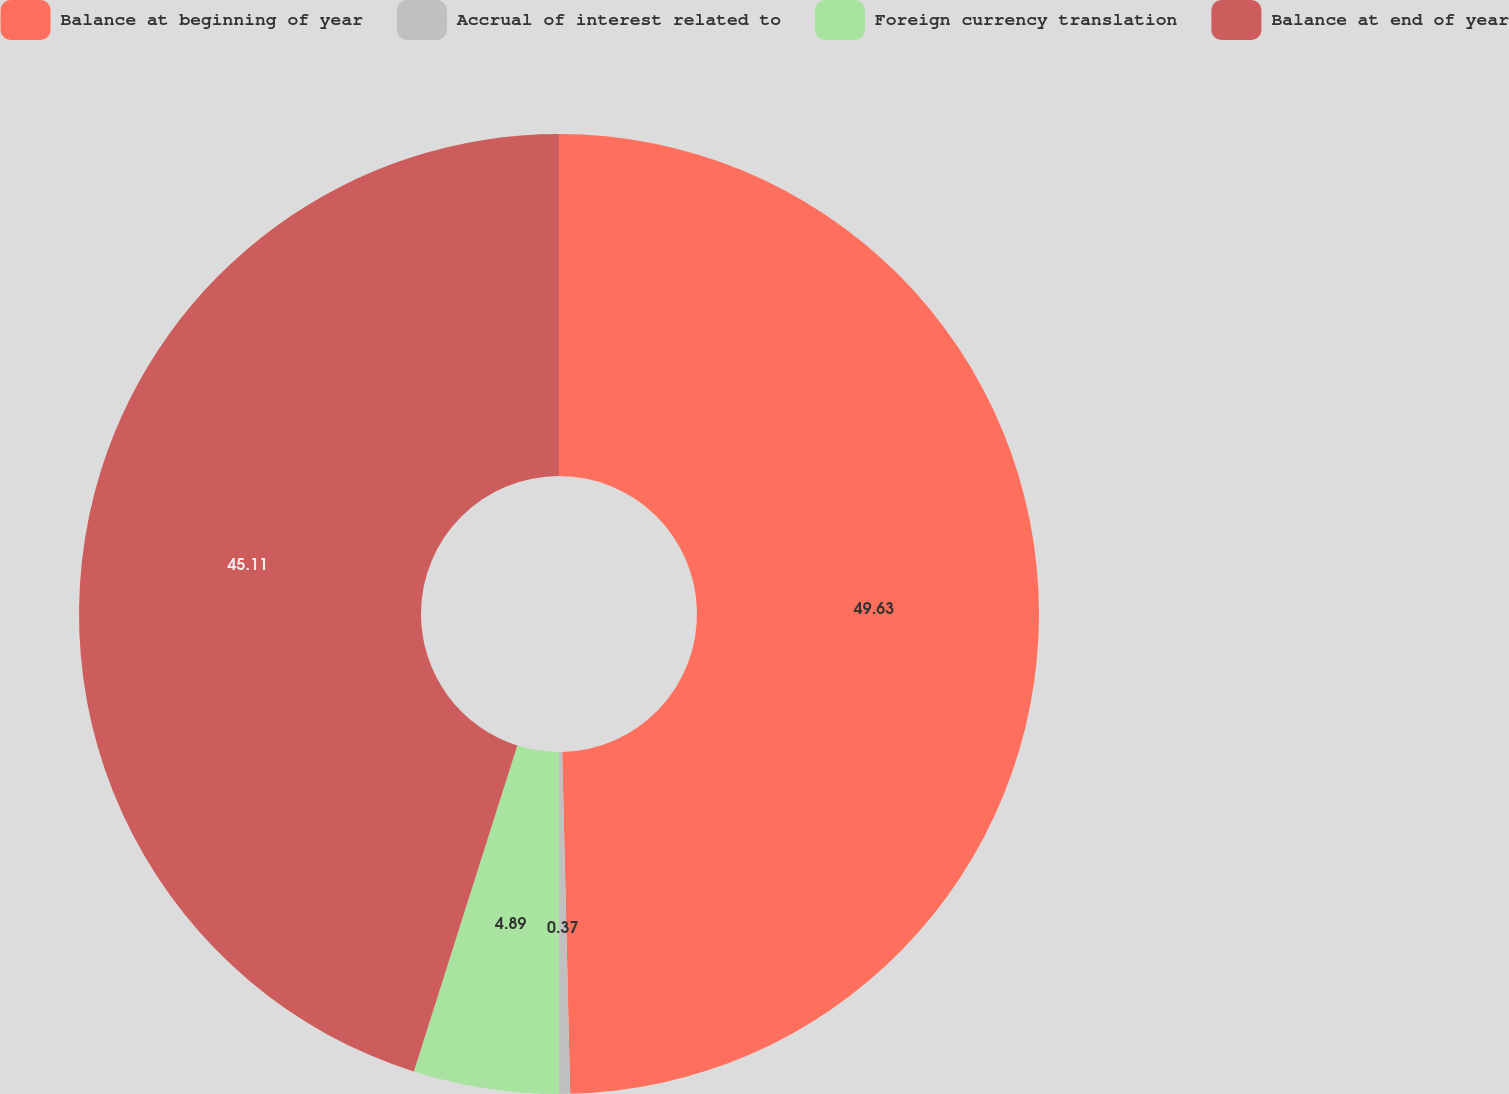<chart> <loc_0><loc_0><loc_500><loc_500><pie_chart><fcel>Balance at beginning of year<fcel>Accrual of interest related to<fcel>Foreign currency translation<fcel>Balance at end of year<nl><fcel>49.63%<fcel>0.37%<fcel>4.89%<fcel>45.11%<nl></chart> 